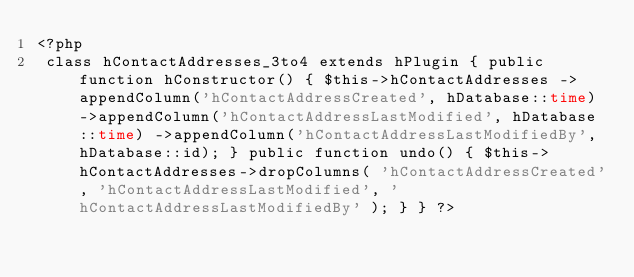Convert code to text. <code><loc_0><loc_0><loc_500><loc_500><_PHP_><?php
 class hContactAddresses_3to4 extends hPlugin { public function hConstructor() { $this->hContactAddresses ->appendColumn('hContactAddressCreated', hDatabase::time) ->appendColumn('hContactAddressLastModified', hDatabase::time) ->appendColumn('hContactAddressLastModifiedBy', hDatabase::id); } public function undo() { $this->hContactAddresses->dropColumns( 'hContactAddressCreated', 'hContactAddressLastModified', 'hContactAddressLastModifiedBy' ); } } ?></code> 